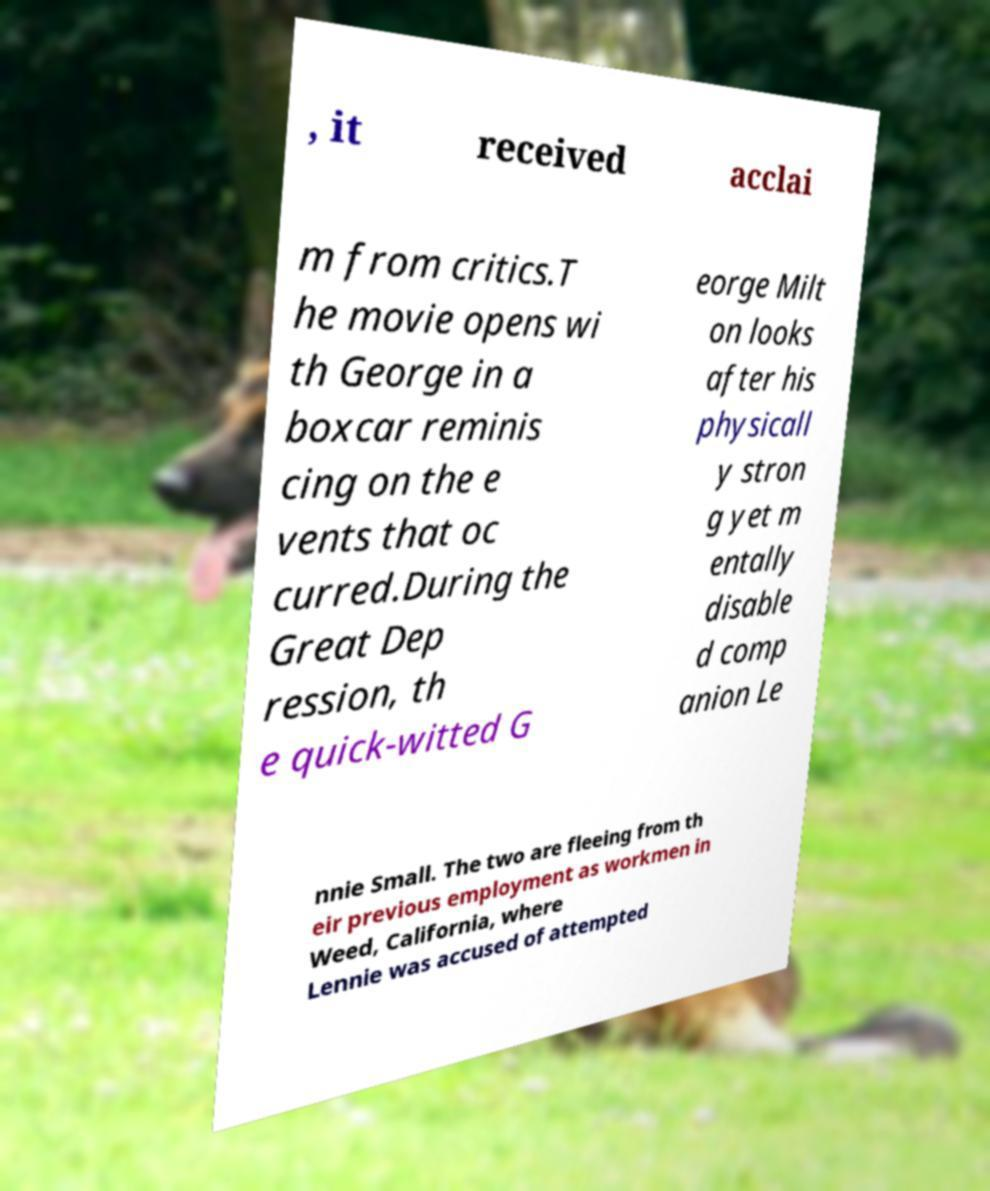Can you accurately transcribe the text from the provided image for me? , it received acclai m from critics.T he movie opens wi th George in a boxcar reminis cing on the e vents that oc curred.During the Great Dep ression, th e quick-witted G eorge Milt on looks after his physicall y stron g yet m entally disable d comp anion Le nnie Small. The two are fleeing from th eir previous employment as workmen in Weed, California, where Lennie was accused of attempted 